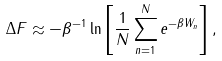Convert formula to latex. <formula><loc_0><loc_0><loc_500><loc_500>\Delta F \approx - \beta ^ { - 1 } \ln \left [ \frac { 1 } { N } \sum _ { n = 1 } ^ { N } e ^ { - \beta W _ { n } } \right ] ,</formula> 